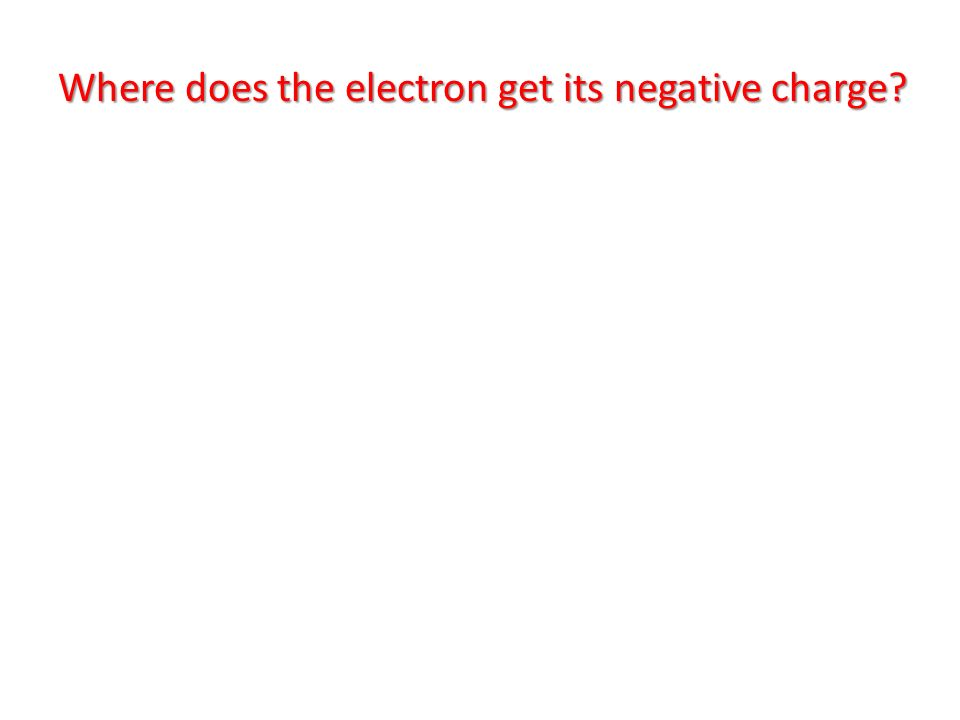In a world where colors dictate the importance of questions, how might different colors be used to categorize and prioritize various types of queries? In a world where colors dictate the importance of questions, different colors could be used as a visual hierarchy to categorize and prioritize various types of queries effectively. For example: 
1. **Red**: Reserved for high-importance or urgent questions, requiring immediate attention, often related to safety, alerts, or critical information. 
2. **Yellow**: Used for questions of moderate importance or ones that need timely responses, such as those related to ongoing issues or investigations. 
3. **Green**: Represents regular, non-urgent questions. These might relate to standard information or general inquiries. 
4. **Blue**: Could be assigned to technical or scientific questions, indicating the need for detailed, analytical responses. 
5. **Purple**: Might signify philosophical or creative inquiries, inviting open-ended and imaginative thinking. 
6. **Orange**: Used for guidance and support questions, indicating a need for assistance or advice. 
This color-coded system would help quickly identify and prioritize questions based on their nature and urgency, making information management more efficient. Can you provide a specific example of how this color-coding system might work in a school setting? In a school setting, a color-coding system to prioritize questions could greatly enhance classroom management and ensure that critical queries are addressed promptly. Here’s a specific example: 
1. **Red**: A question such as, “What should we do in case of a fire drill?” This is urgent and requires immediate attention, so it is color-coded red. 
2. **Yellow**: A question like, “When is the deadline for submitting the science project?” This is important but not immediately urgent, warranting a yellow tag. 
3. **Green**: General inquiries such as, “Can you explain the homework assignment?” This can be addressed during regular class time and is coded green. 
4. **Blue**: Technical questions like, “How does photosynthesis work in plants?” These require detailed, educational responses and are color-coded blue. 
5. **Purple**: Creative inquiries like, “What if plants could talk?” encourage imaginative thinking and are coded purple. 
6. **Orange**: Supportive questions like, “Can you help me understand this math problem?” signify a need for additional help and are tagged orange. 
This system ensures that important safety and urgent questions are prioritized, while still addressing all students’ needs in a structured manner. 